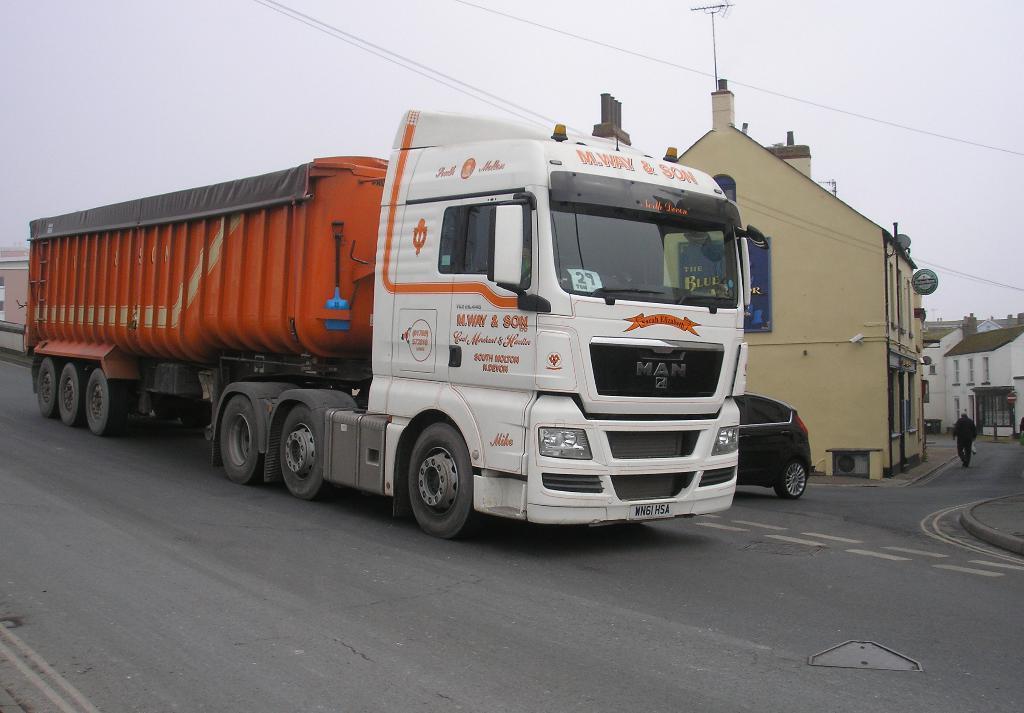How would you summarize this image in a sentence or two? In this image, I can see the vehicles on the road. Here is a person walking. These are the buildings. This looks like a board, which is attached to a building wall. Here is a sky. 